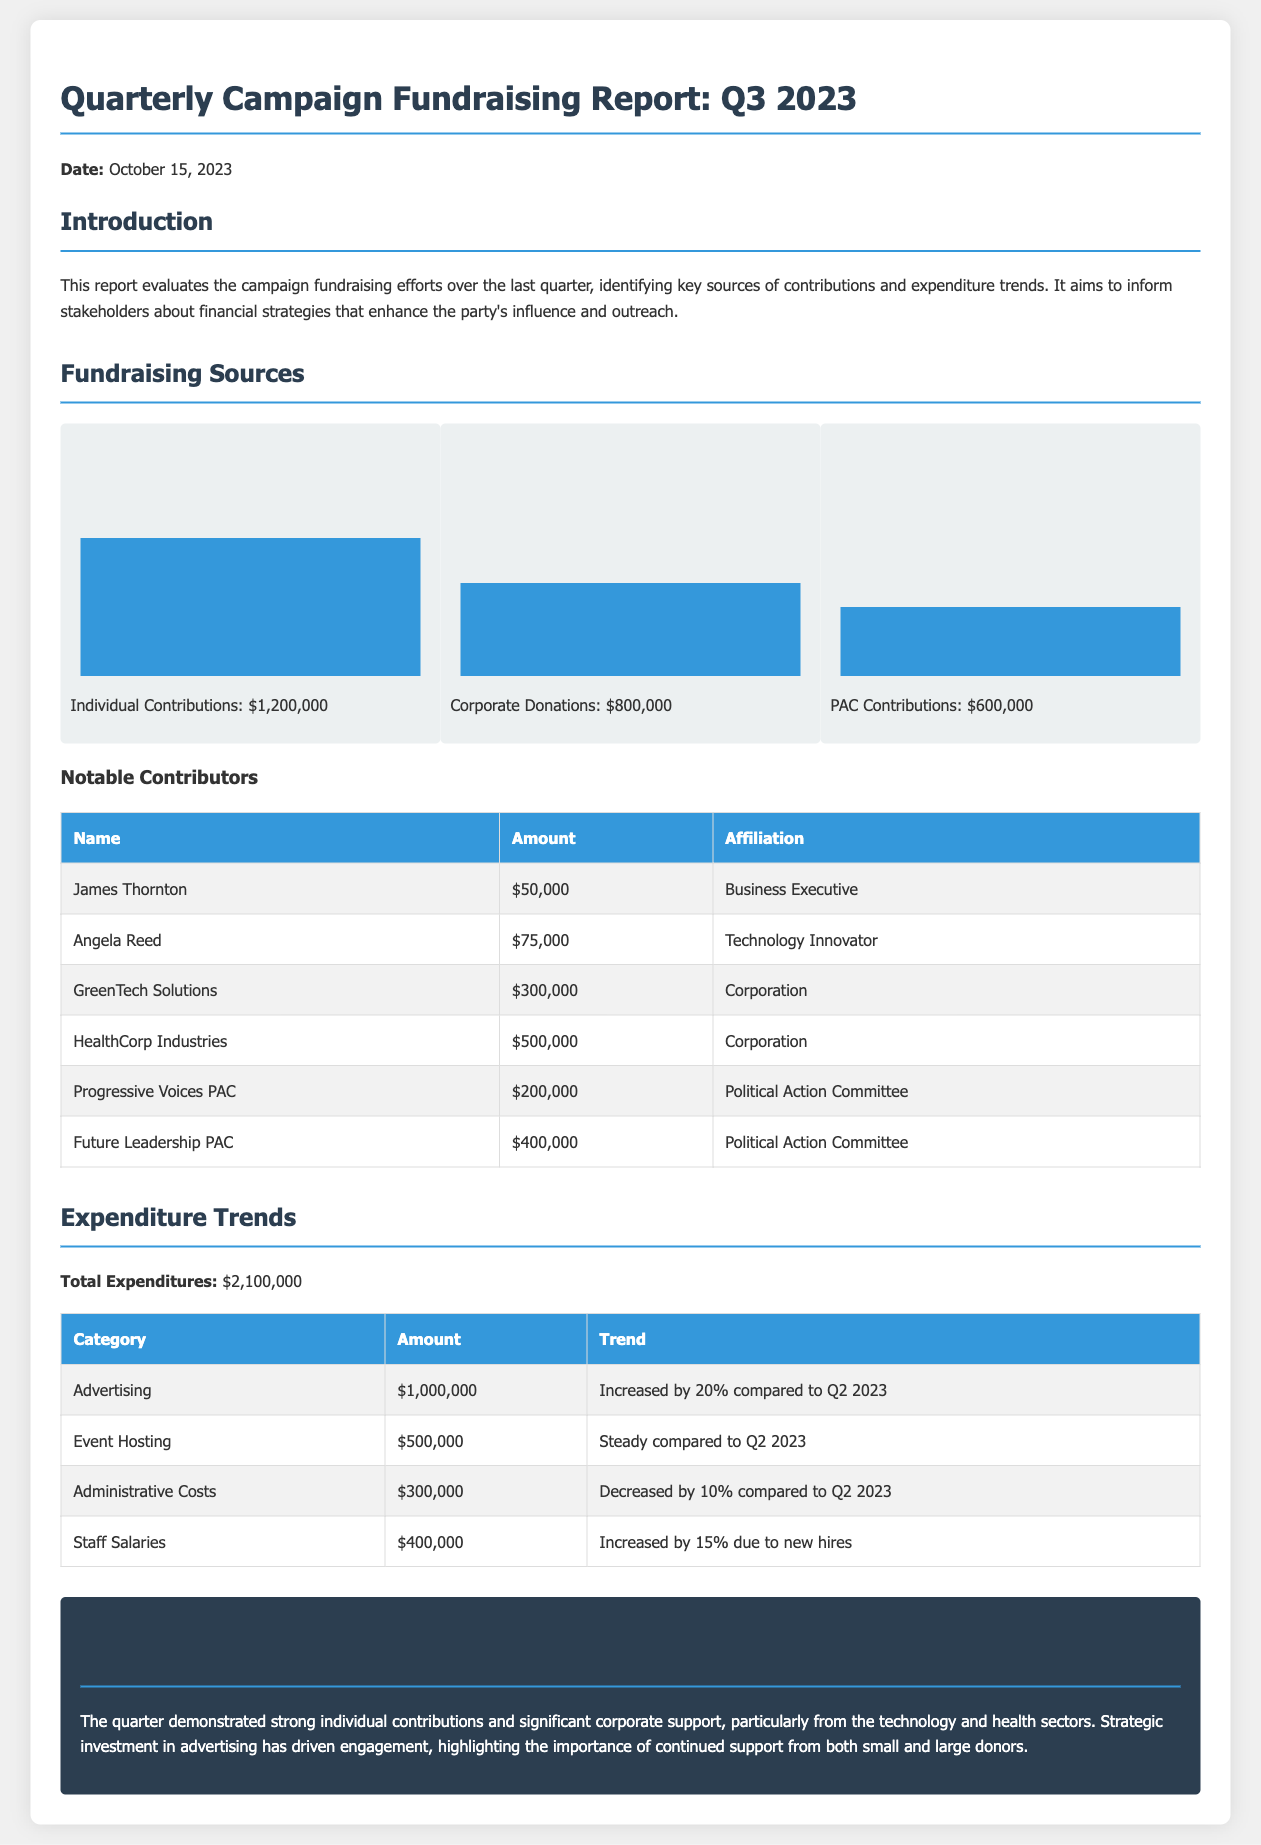What is the total amount of individual contributions? The total amount of individual contributions is provided in the section on fundraising sources, which states $1,200,000.
Answer: $1,200,000 What is the total expenditure for the quarter? The total expenditure is explicitly mentioned in the expenditure trends section as $2,100,000.
Answer: $2,100,000 Which corporation contributed the most amount? The document lists notable contributors, with HealthCorp Industries contributing the largest amount of $500,000.
Answer: HealthCorp Industries By what percentage did advertising expenditures increase compared to Q2 2023? The document notes that advertising expenditures increased by 20% compared to Q2 2023.
Answer: 20% What was the expenditure amount on staff salaries? The expenditure amount for staff salaries is detailed in the table, listed as $400,000.
Answer: $400,000 How much did Progressive Voices PAC contribute? The contribution from Progressive Voices PAC is specified in the notable contributors section as $200,000.
Answer: $200,000 What is the focus of the conclusion section? The conclusion summarizes the financial performance of the quarter, focusing on strong individual contributions and corporate support, especially from technology and health sectors.
Answer: Strong individual contributions and significant corporate support Which category of expenditure saw a decrease compared to Q2 2023? The administrative costs showed a decrease compared to Q2 2023, as indicated in the expenditure trends section.
Answer: Administrative Costs How many notable contributors are listed in the report? The report provides a table that includes six notable contributors.
Answer: Six 